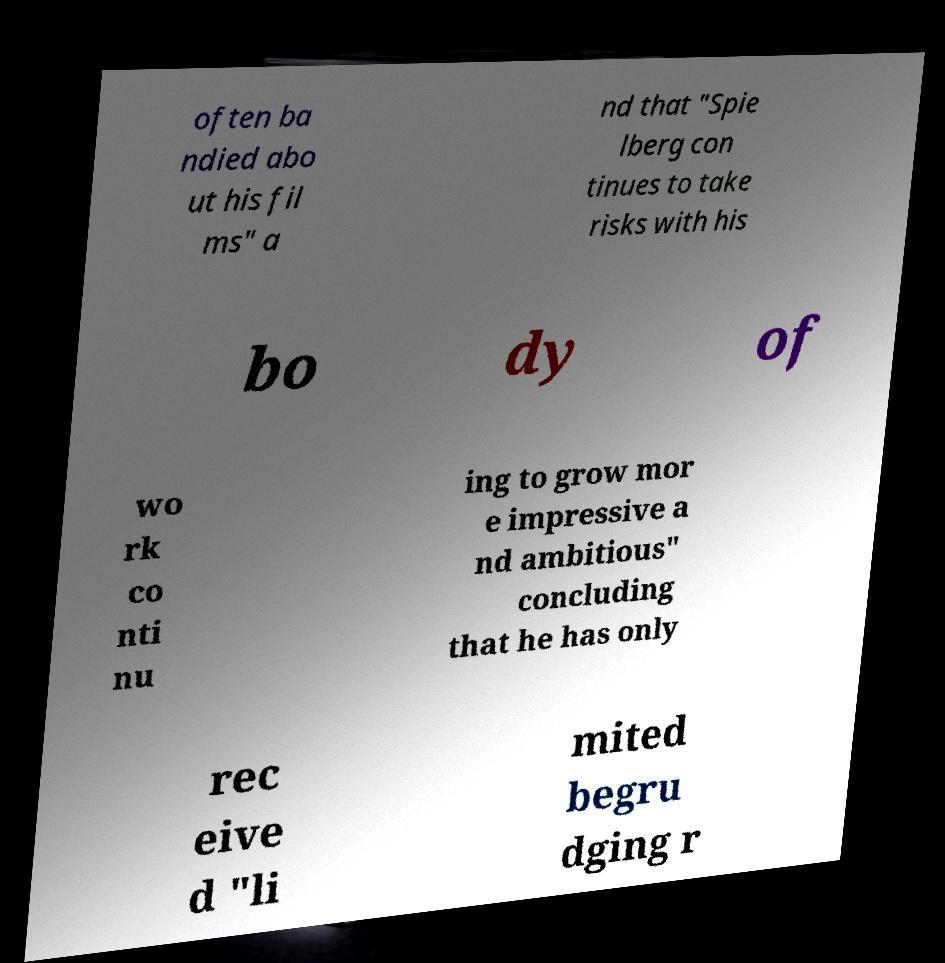There's text embedded in this image that I need extracted. Can you transcribe it verbatim? often ba ndied abo ut his fil ms" a nd that "Spie lberg con tinues to take risks with his bo dy of wo rk co nti nu ing to grow mor e impressive a nd ambitious" concluding that he has only rec eive d "li mited begru dging r 